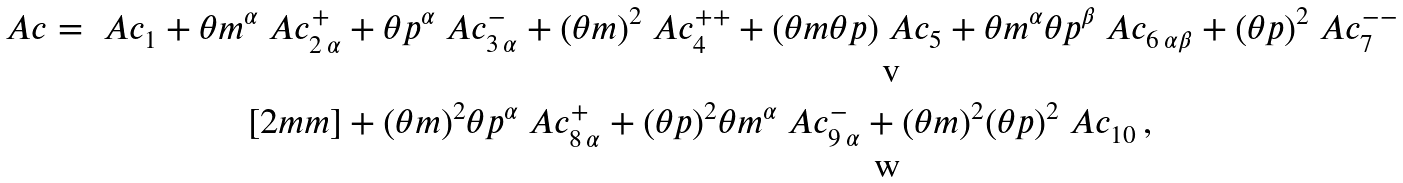<formula> <loc_0><loc_0><loc_500><loc_500>\ A c = \ A c _ { 1 } + \theta m ^ { \alpha } \ A c ^ { + } _ { 2 \, \alpha } & + \theta p ^ { \alpha } \ A c ^ { - } _ { 3 \, \alpha } + ( \theta m ) ^ { 2 } \ A c ^ { + + } _ { 4 } + ( \theta m \theta p ) \ A c _ { 5 } + \theta m ^ { \alpha } \theta p ^ { \beta } \ A c _ { 6 \, \alpha \beta } + ( \theta p ) ^ { 2 } \ A c ^ { - - } _ { 7 } \\ [ 2 m m ] & + ( \theta m ) ^ { 2 } \theta p ^ { \alpha } \ A c ^ { + } _ { 8 \, \alpha } + ( \theta p ) ^ { 2 } \theta m ^ { \alpha } \ A c ^ { - } _ { 9 \, \alpha } + ( \theta m ) ^ { 2 } ( \theta p ) ^ { 2 } \ A c _ { 1 0 } \, ,</formula> 